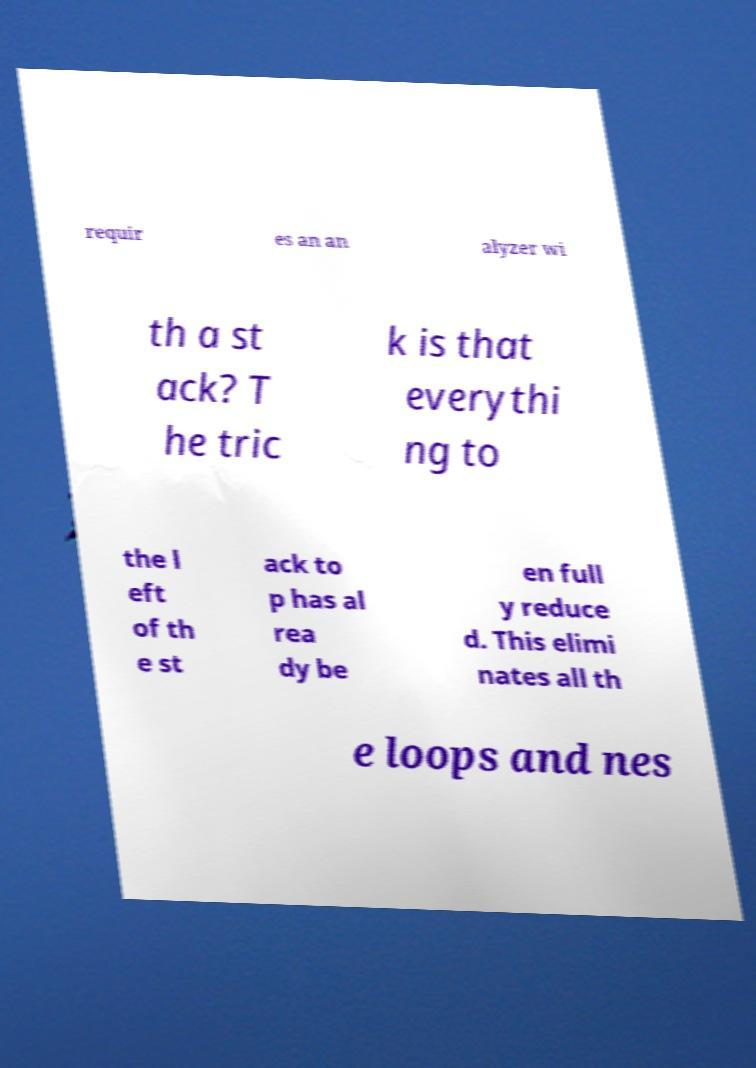Please read and relay the text visible in this image. What does it say? requir es an an alyzer wi th a st ack? T he tric k is that everythi ng to the l eft of th e st ack to p has al rea dy be en full y reduce d. This elimi nates all th e loops and nes 